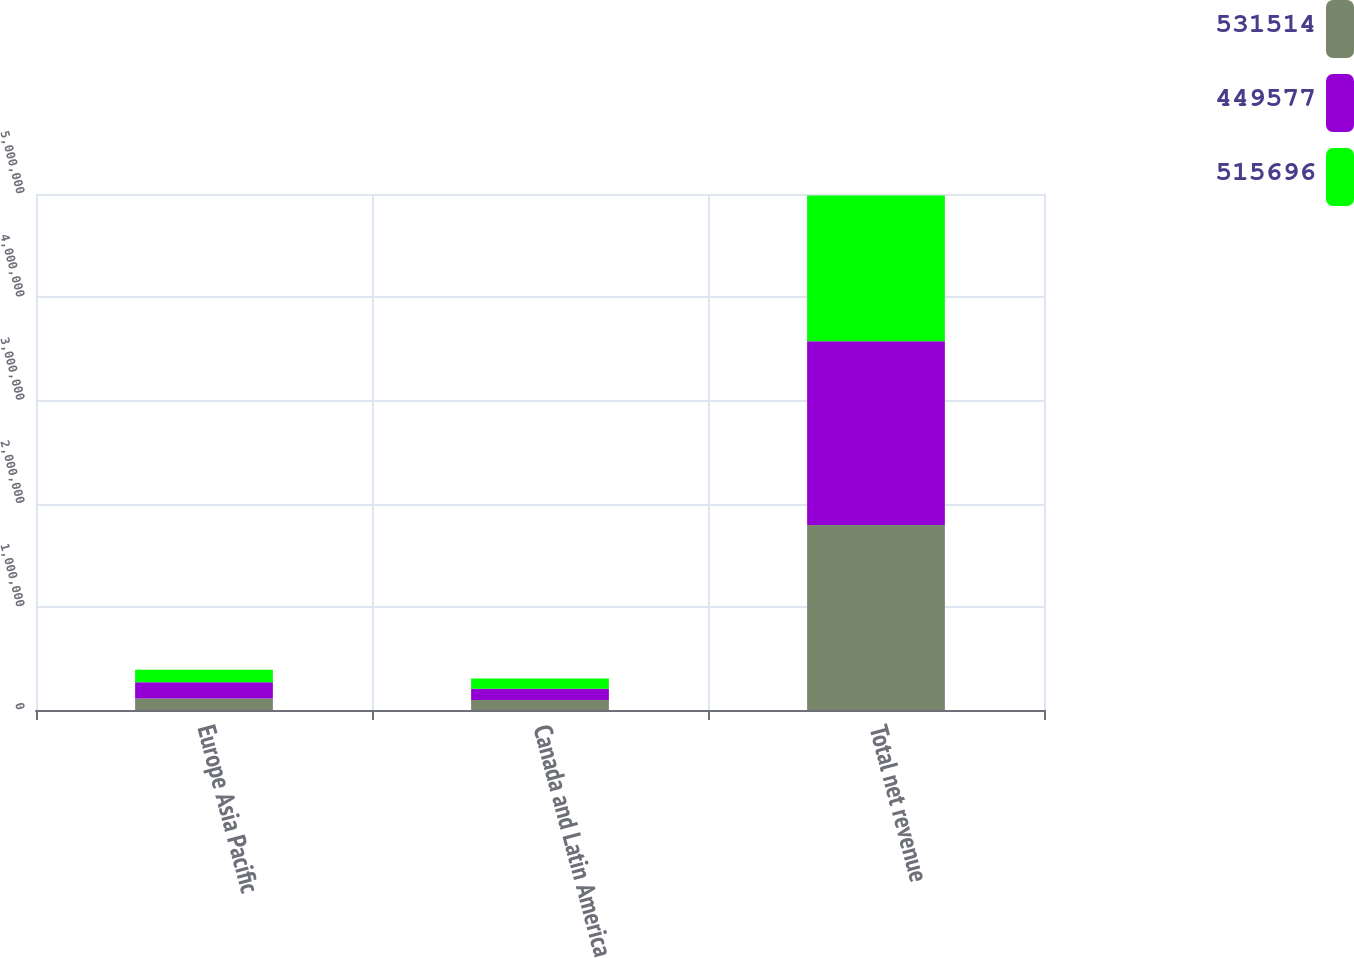Convert chart to OTSL. <chart><loc_0><loc_0><loc_500><loc_500><stacked_bar_chart><ecel><fcel>Europe Asia Pacific<fcel>Canada and Latin America<fcel>Total net revenue<nl><fcel>531514<fcel>111223<fcel>97842<fcel>1.79289e+06<nl><fcel>449577<fcel>157183<fcel>107741<fcel>1.77975e+06<nl><fcel>515696<fcel>120629<fcel>100529<fcel>1.4137e+06<nl></chart> 